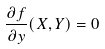Convert formula to latex. <formula><loc_0><loc_0><loc_500><loc_500>\frac { \partial f } { \partial y } ( X , Y ) = 0</formula> 